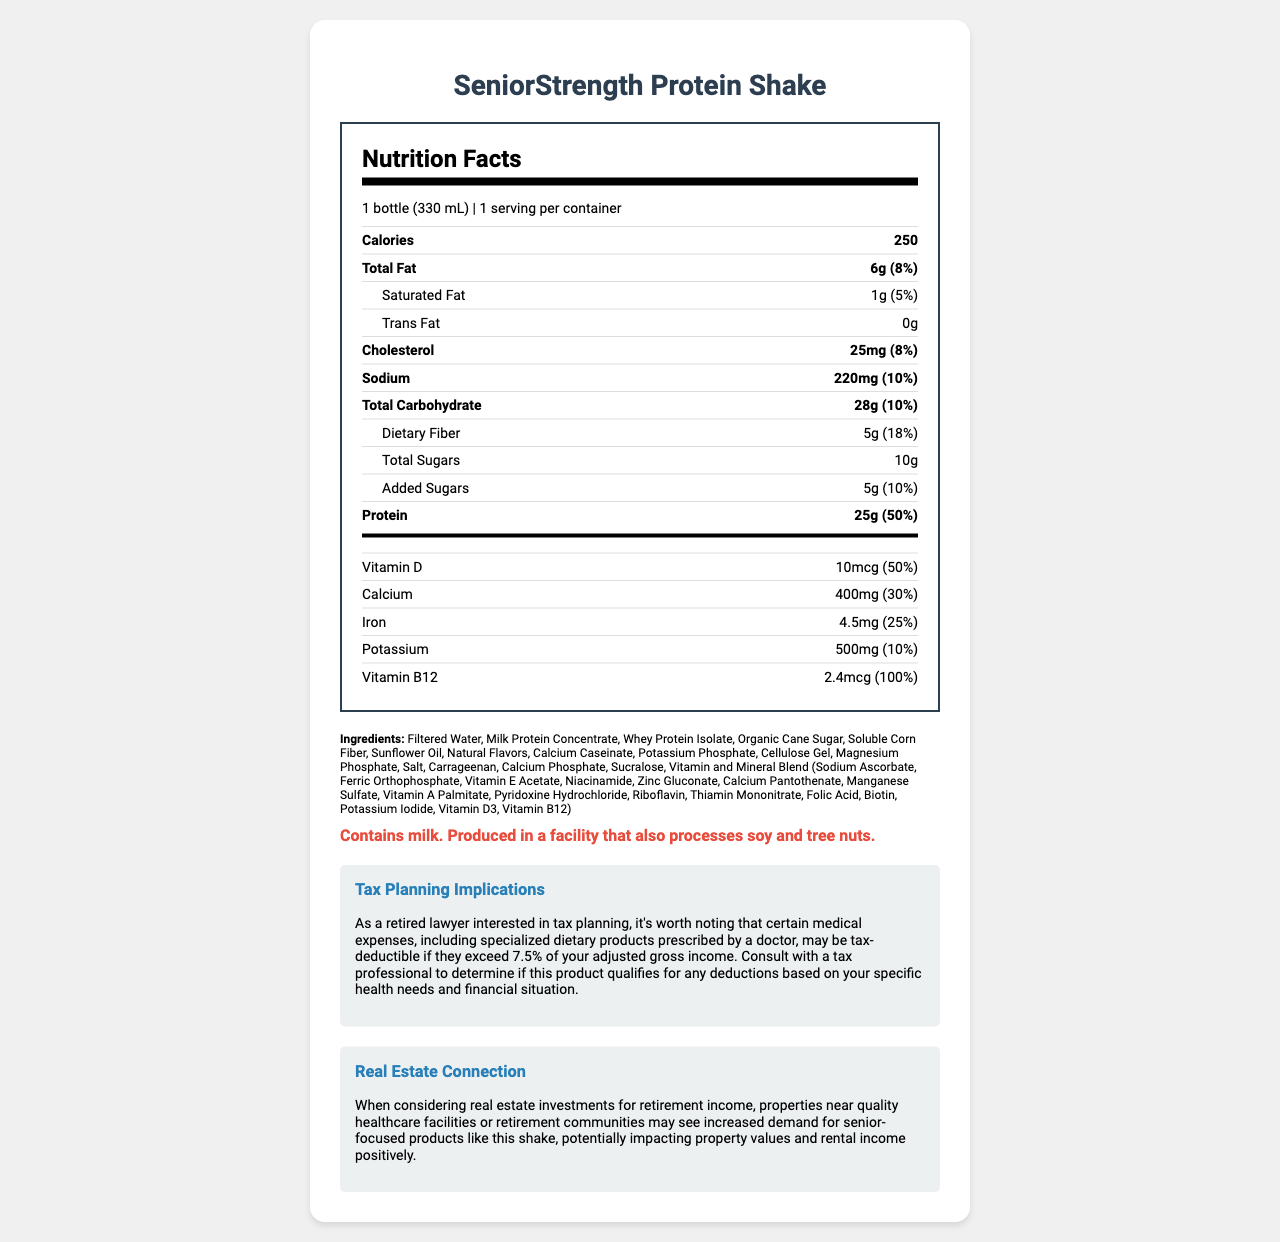what is the serving size of the SeniorStrength Protein Shake? The serving size is listed at the beginning of the Nutrition Facts section as "1 bottle (330 mL)".
Answer: 1 bottle (330 mL) how many grams of protein does each serving contain? The protein amount is explicitly stated as 25g in the Nutrition Facts.
Answer: 25g what percentage of the daily value of Vitamin B12 is provided per serving? The document states that each serving provides 2.4mcg of Vitamin B12, which is 100% of the daily value.
Answer: 100% what is the total number of calories per serving? The total number of calories per serving is indicated to be 250 in the Nutrition Facts.
Answer: 250 calories is there any trans fat in the SeniorStrength Protein Shake? The Nutrition Facts state that there are 0g of trans fat.
Answer: No what is the main source of the protein in the shake? The ingredients list "Milk Protein Concentrate" as one of the primary sources, indicating it's a main source of protein.
Answer: Milk Protein Concentrate what does the allergen warning indicate? The allergen warning clearly lists milk and mentions potential cross-contamination with soy and tree nuts.
Answer: Contains milk. Produced in a facility that also processes soy and tree nuts. how many servings are there per container? The document states "1 serving per container" at the top of the Nutrition Facts.
Answer: 1 how does this product relate to real estate investments? A. Provides nutritional benefits B. Impacts property values C. Helps with tax planning The document connects the product to real estate investments by suggesting that properties near quality healthcare facilities or retirement communities may see increased demand for senior-focused products like this shake, potentially impacting property values and rental income.
Answer: B which vitamin is provided at 50% daily value per serving? A. Vitamin A B. Vitamin C C. Vitamin D According to the Nutrition Facts, Vitamin D is provided at 50% of the daily value per serving.
Answer: C is the SeniorStrength Protein Shake likely to be tax-deductible? The tax deducibility is based on whether the product is prescribed by a doctor as a medical expense and if it exceeds 7.5% of adjusted gross income.
Answer: It depends summarize the main features of the SeniorStrength Protein Shake. The summary details the main nutritional content, ingredients, allergen warnings, tax implications, and potential impact on real estate, providing a comprehensive overview of the product’s features.
Answer: The SeniorStrength Protein Shake is a high-protein meal replacement designed for seniors, containing 250 calories per serving with 25g of protein and a variety of vitamins and minerals. It includes ingredients like Milk Protein Concentrate and Whey Protein Isolate and provides significant daily values of several nutrients. The product also contains allergens such as milk and notes potential cross-contamination with soy and tree nuts. It may have tax planning implications if deemed medically necessary and could positively impact property values in certain real estate markets. how long has the product been on the market? The document does not provide any information about when the product was launched or how long it has been available on the market.
Answer: Not enough information 